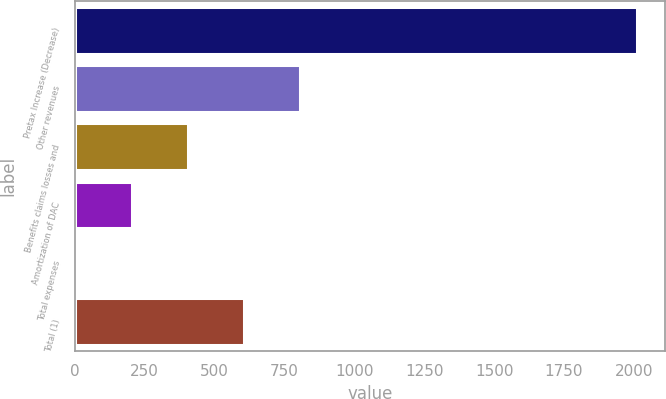<chart> <loc_0><loc_0><loc_500><loc_500><bar_chart><fcel>Pretax Increase (Decrease)<fcel>Other revenues<fcel>Benefits claims losses and<fcel>Amortization of DAC<fcel>Total expenses<fcel>Total (1)<nl><fcel>2012<fcel>806.6<fcel>404.8<fcel>203.9<fcel>3<fcel>605.7<nl></chart> 